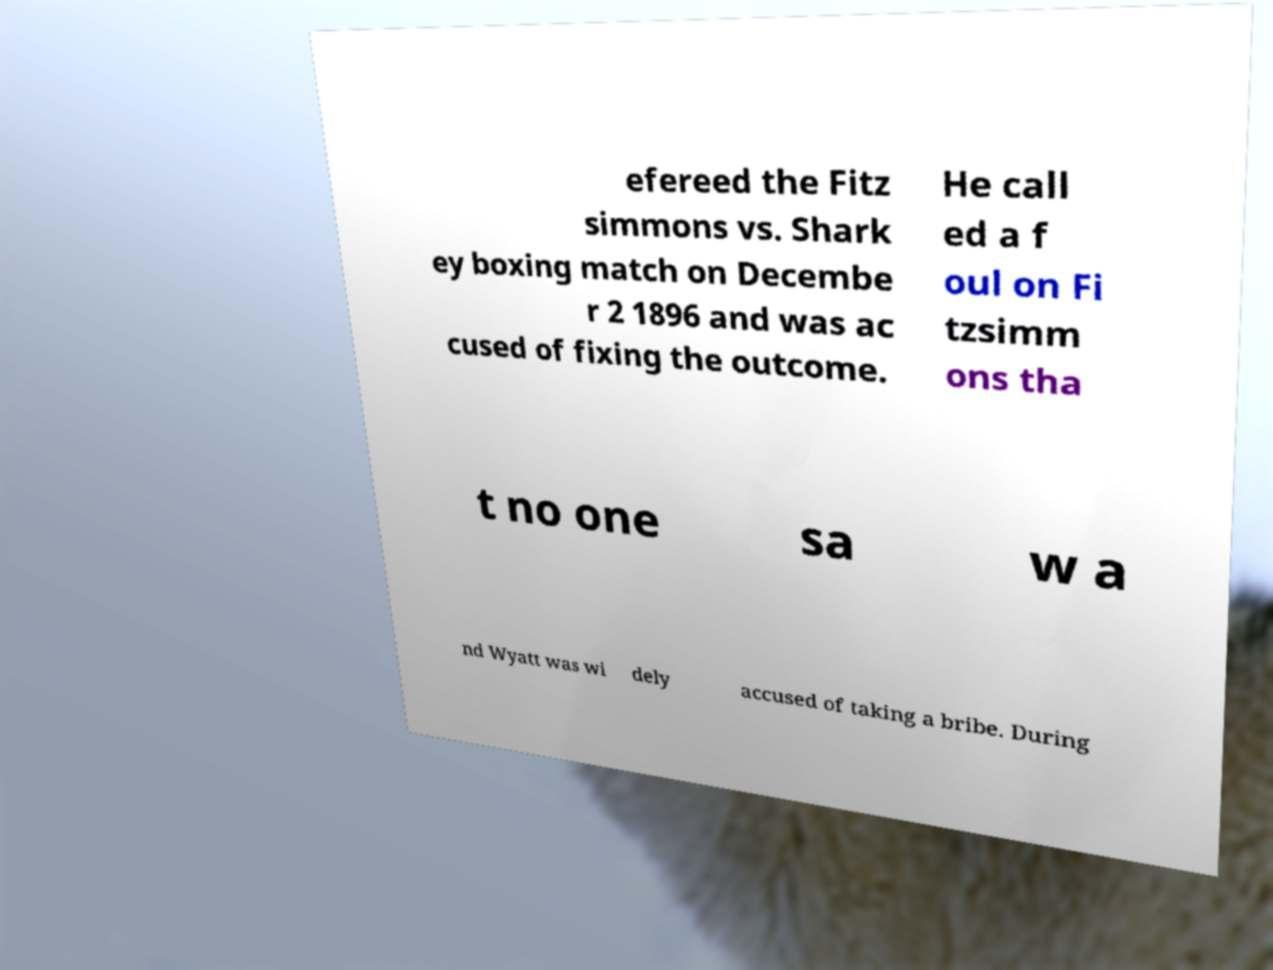Could you assist in decoding the text presented in this image and type it out clearly? efereed the Fitz simmons vs. Shark ey boxing match on Decembe r 2 1896 and was ac cused of fixing the outcome. He call ed a f oul on Fi tzsimm ons tha t no one sa w a nd Wyatt was wi dely accused of taking a bribe. During 